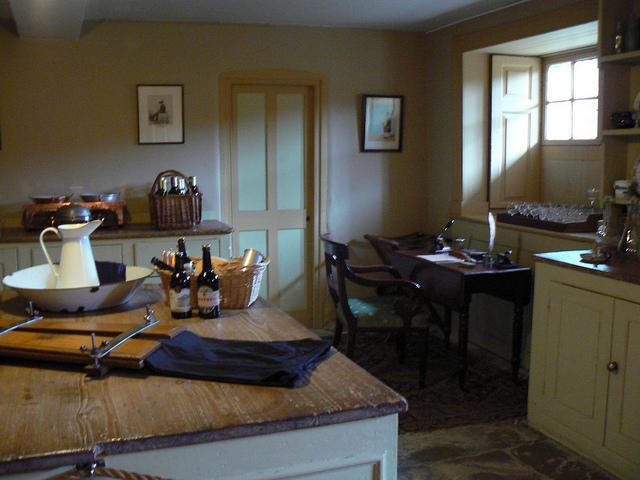How many pictures are hanging on the wall? Please explain your reasoning. two. There are two pictures hanging on the wall on each side of the door 